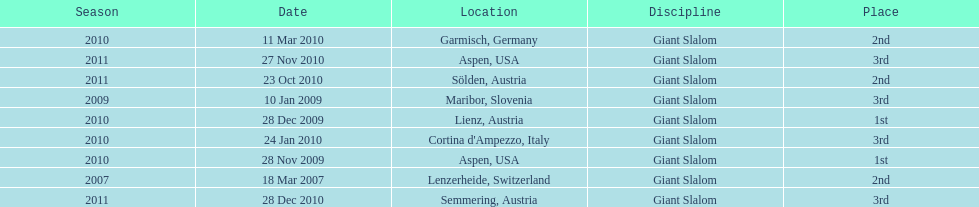Aspen and lienz in 2009 are the only races where this racer got what position? 1st. 